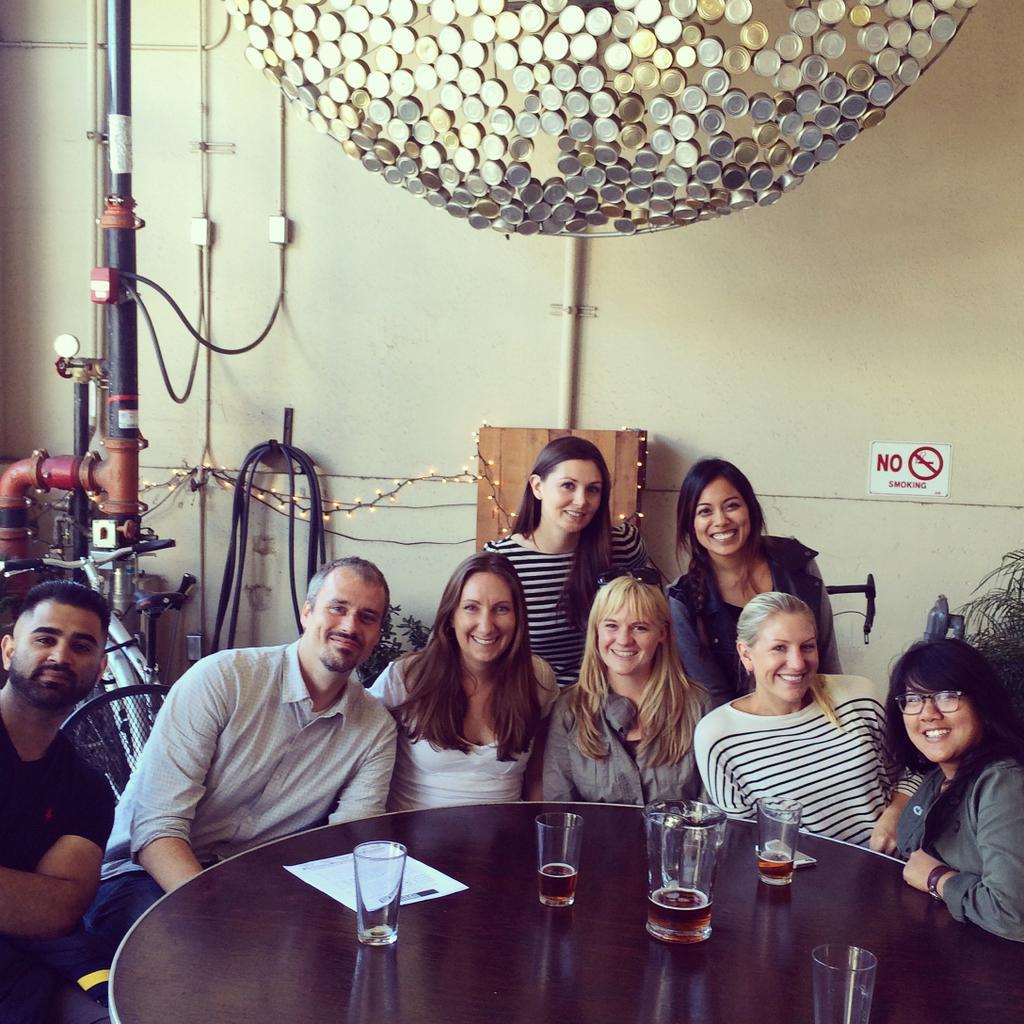Describe this image in one or two sentences. In this image, In the middle there is a table which is in black color on that table there are some glasses and there are some people sitting around the table in the background there is a wall of white color and there is a ball of yellow color. 